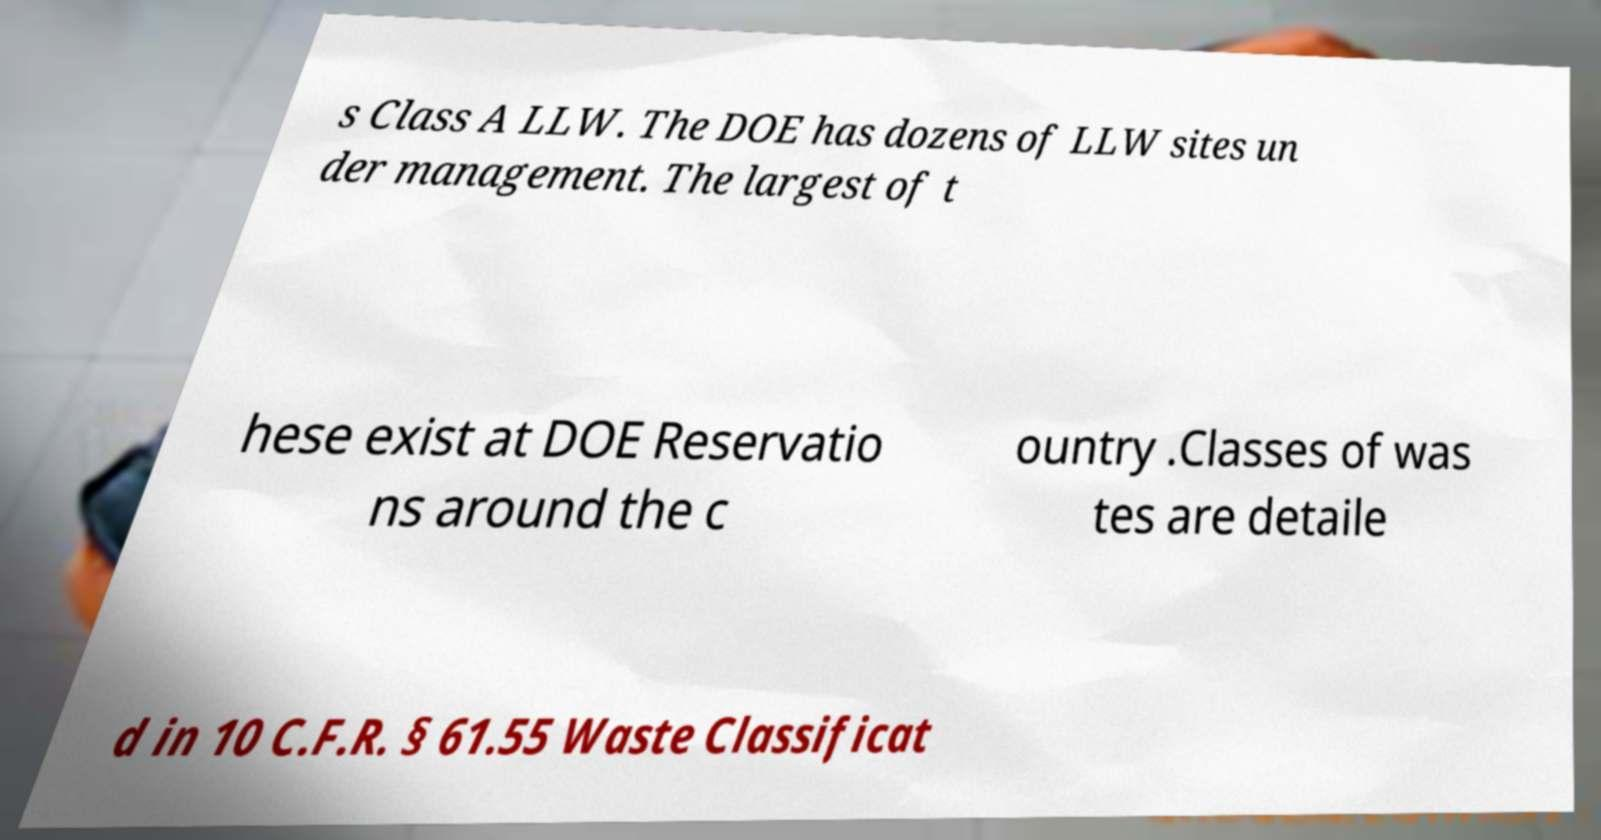Please read and relay the text visible in this image. What does it say? s Class A LLW. The DOE has dozens of LLW sites un der management. The largest of t hese exist at DOE Reservatio ns around the c ountry .Classes of was tes are detaile d in 10 C.F.R. § 61.55 Waste Classificat 